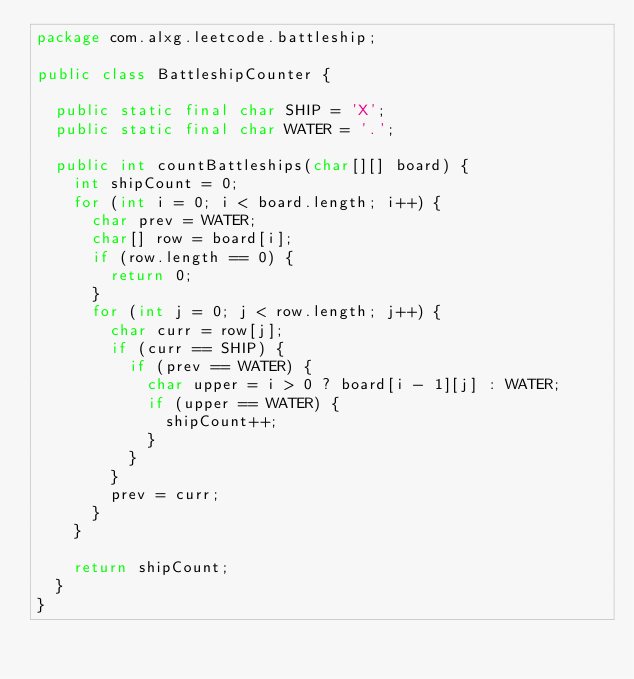Convert code to text. <code><loc_0><loc_0><loc_500><loc_500><_Java_>package com.alxg.leetcode.battleship;

public class BattleshipCounter {

  public static final char SHIP = 'X';
  public static final char WATER = '.';

  public int countBattleships(char[][] board) {
    int shipCount = 0;
    for (int i = 0; i < board.length; i++) {
      char prev = WATER;
      char[] row = board[i];
      if (row.length == 0) {
        return 0;
      }
      for (int j = 0; j < row.length; j++) {
        char curr = row[j];
        if (curr == SHIP) {
          if (prev == WATER) {
            char upper = i > 0 ? board[i - 1][j] : WATER;
            if (upper == WATER) {
              shipCount++;
            }
          }
        }
        prev = curr;
      }
    }

    return shipCount;
  }
}
</code> 